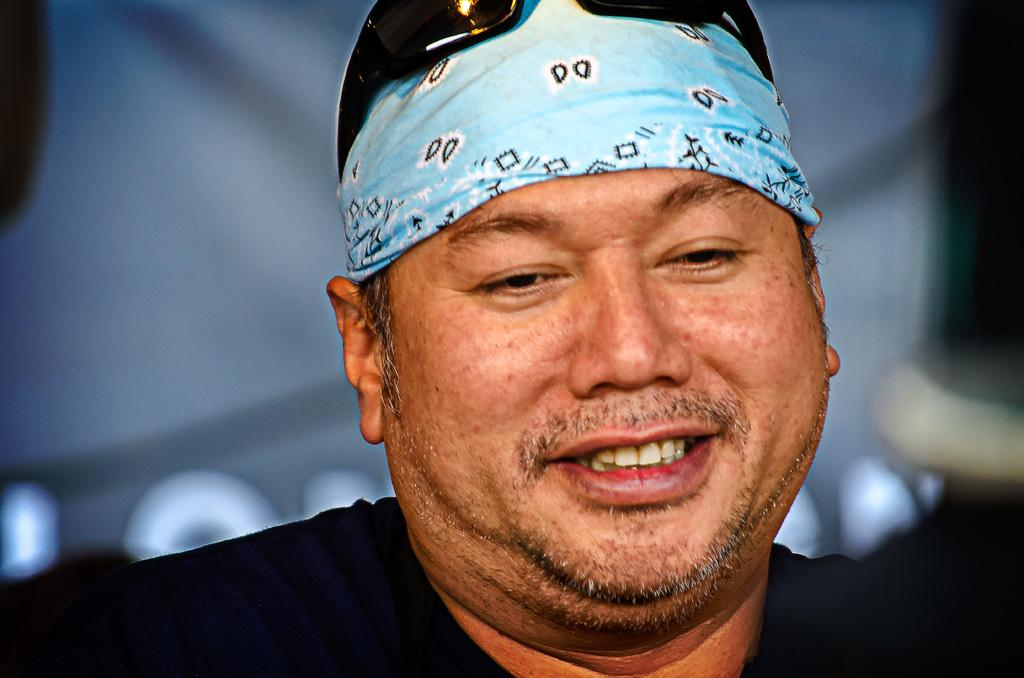Who is the main subject in the picture? There is a man in the picture. What is the man wearing on his upper body? The man is wearing a black shirt. What type of headwear is the man wearing? The man is wearing headwear. Does the man have any accessories on his face? Yes, the man has glasses. What is the man's facial expression in the picture? The man is smiling. Can you describe the background of the picture? The backdrop is blurred. What type of point is the man making with the rod in the image? There is no rod or point-making action present in the image. 